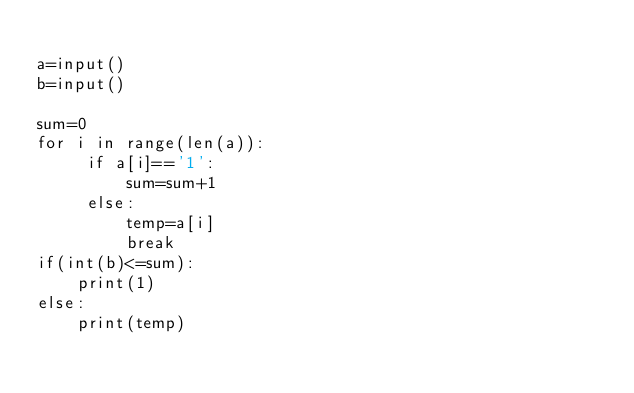<code> <loc_0><loc_0><loc_500><loc_500><_Python_>
a=input()
b=input()

sum=0
for i in range(len(a)):
     if a[i]=='1':
         sum=sum+1
     else:
         temp=a[i]
         break
if(int(b)<=sum):
    print(1)
else:
    print(temp)</code> 